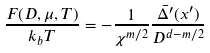<formula> <loc_0><loc_0><loc_500><loc_500>\frac { F ( D , \mu , T ) } { k _ { b } T } = - \frac { 1 } { \chi ^ { m / 2 } } \frac { \bar { \Delta ^ { \prime } } ( x ^ { \prime } ) } { D ^ { d - m / 2 } }</formula> 